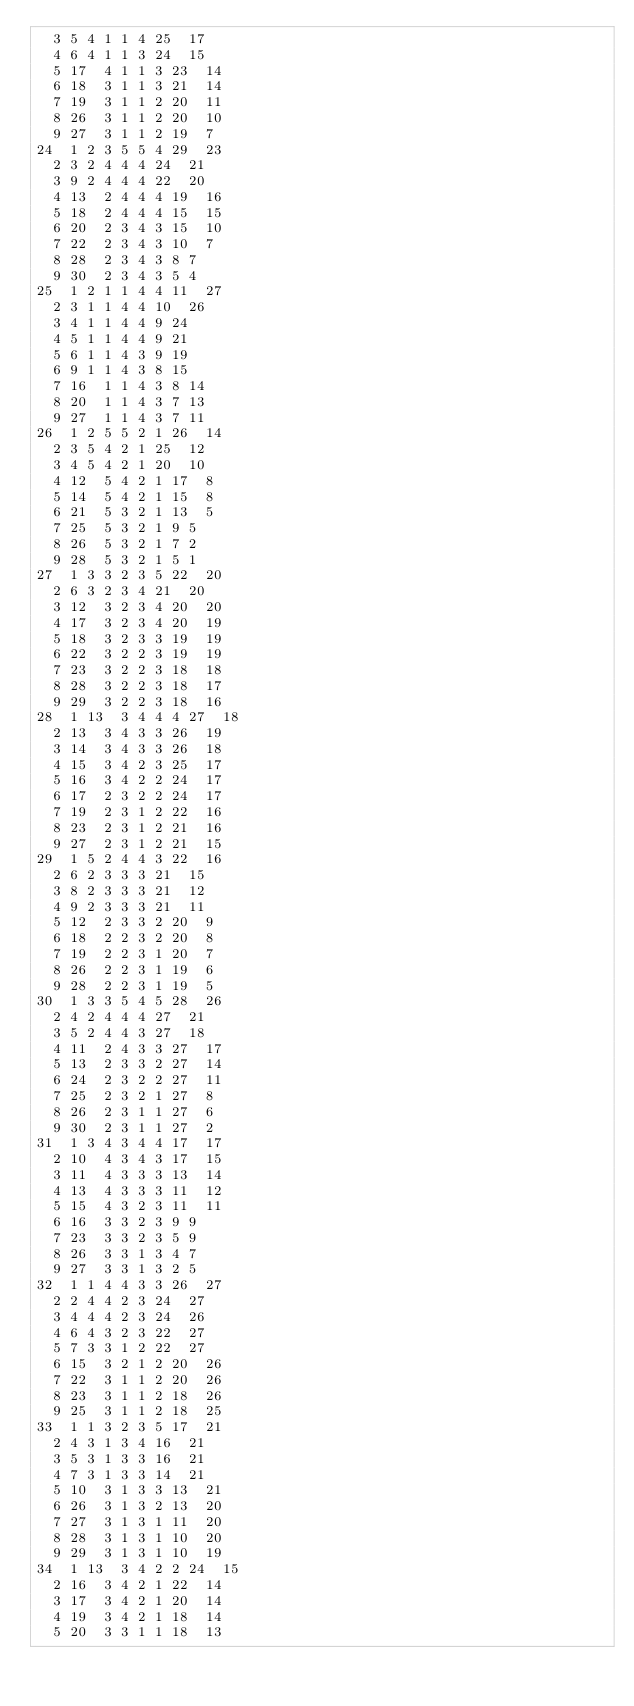Convert code to text. <code><loc_0><loc_0><loc_500><loc_500><_ObjectiveC_>	3	5	4	1	1	4	25	17	
	4	6	4	1	1	3	24	15	
	5	17	4	1	1	3	23	14	
	6	18	3	1	1	3	21	14	
	7	19	3	1	1	2	20	11	
	8	26	3	1	1	2	20	10	
	9	27	3	1	1	2	19	7	
24	1	2	3	5	5	4	29	23	
	2	3	2	4	4	4	24	21	
	3	9	2	4	4	4	22	20	
	4	13	2	4	4	4	19	16	
	5	18	2	4	4	4	15	15	
	6	20	2	3	4	3	15	10	
	7	22	2	3	4	3	10	7	
	8	28	2	3	4	3	8	7	
	9	30	2	3	4	3	5	4	
25	1	2	1	1	4	4	11	27	
	2	3	1	1	4	4	10	26	
	3	4	1	1	4	4	9	24	
	4	5	1	1	4	4	9	21	
	5	6	1	1	4	3	9	19	
	6	9	1	1	4	3	8	15	
	7	16	1	1	4	3	8	14	
	8	20	1	1	4	3	7	13	
	9	27	1	1	4	3	7	11	
26	1	2	5	5	2	1	26	14	
	2	3	5	4	2	1	25	12	
	3	4	5	4	2	1	20	10	
	4	12	5	4	2	1	17	8	
	5	14	5	4	2	1	15	8	
	6	21	5	3	2	1	13	5	
	7	25	5	3	2	1	9	5	
	8	26	5	3	2	1	7	2	
	9	28	5	3	2	1	5	1	
27	1	3	3	2	3	5	22	20	
	2	6	3	2	3	4	21	20	
	3	12	3	2	3	4	20	20	
	4	17	3	2	3	4	20	19	
	5	18	3	2	3	3	19	19	
	6	22	3	2	2	3	19	19	
	7	23	3	2	2	3	18	18	
	8	28	3	2	2	3	18	17	
	9	29	3	2	2	3	18	16	
28	1	13	3	4	4	4	27	18	
	2	13	3	4	3	3	26	19	
	3	14	3	4	3	3	26	18	
	4	15	3	4	2	3	25	17	
	5	16	3	4	2	2	24	17	
	6	17	2	3	2	2	24	17	
	7	19	2	3	1	2	22	16	
	8	23	2	3	1	2	21	16	
	9	27	2	3	1	2	21	15	
29	1	5	2	4	4	3	22	16	
	2	6	2	3	3	3	21	15	
	3	8	2	3	3	3	21	12	
	4	9	2	3	3	3	21	11	
	5	12	2	3	3	2	20	9	
	6	18	2	2	3	2	20	8	
	7	19	2	2	3	1	20	7	
	8	26	2	2	3	1	19	6	
	9	28	2	2	3	1	19	5	
30	1	3	3	5	4	5	28	26	
	2	4	2	4	4	4	27	21	
	3	5	2	4	4	3	27	18	
	4	11	2	4	3	3	27	17	
	5	13	2	3	3	2	27	14	
	6	24	2	3	2	2	27	11	
	7	25	2	3	2	1	27	8	
	8	26	2	3	1	1	27	6	
	9	30	2	3	1	1	27	2	
31	1	3	4	3	4	4	17	17	
	2	10	4	3	4	3	17	15	
	3	11	4	3	3	3	13	14	
	4	13	4	3	3	3	11	12	
	5	15	4	3	2	3	11	11	
	6	16	3	3	2	3	9	9	
	7	23	3	3	2	3	5	9	
	8	26	3	3	1	3	4	7	
	9	27	3	3	1	3	2	5	
32	1	1	4	4	3	3	26	27	
	2	2	4	4	2	3	24	27	
	3	4	4	4	2	3	24	26	
	4	6	4	3	2	3	22	27	
	5	7	3	3	1	2	22	27	
	6	15	3	2	1	2	20	26	
	7	22	3	1	1	2	20	26	
	8	23	3	1	1	2	18	26	
	9	25	3	1	1	2	18	25	
33	1	1	3	2	3	5	17	21	
	2	4	3	1	3	4	16	21	
	3	5	3	1	3	3	16	21	
	4	7	3	1	3	3	14	21	
	5	10	3	1	3	3	13	21	
	6	26	3	1	3	2	13	20	
	7	27	3	1	3	1	11	20	
	8	28	3	1	3	1	10	20	
	9	29	3	1	3	1	10	19	
34	1	13	3	4	2	2	24	15	
	2	16	3	4	2	1	22	14	
	3	17	3	4	2	1	20	14	
	4	19	3	4	2	1	18	14	
	5	20	3	3	1	1	18	13	</code> 